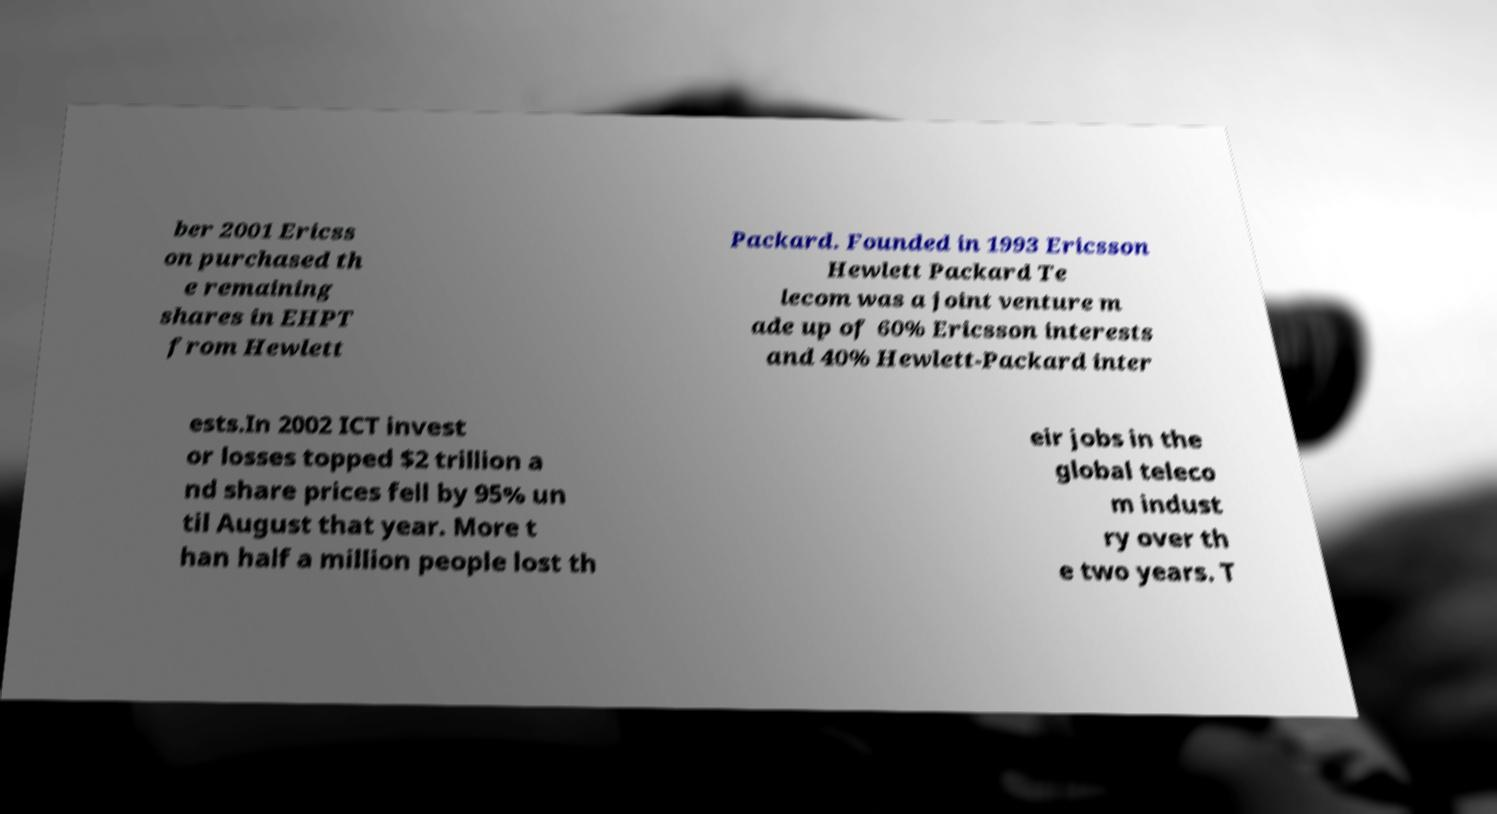Can you read and provide the text displayed in the image?This photo seems to have some interesting text. Can you extract and type it out for me? ber 2001 Ericss on purchased th e remaining shares in EHPT from Hewlett Packard. Founded in 1993 Ericsson Hewlett Packard Te lecom was a joint venture m ade up of 60% Ericsson interests and 40% Hewlett-Packard inter ests.In 2002 ICT invest or losses topped $2 trillion a nd share prices fell by 95% un til August that year. More t han half a million people lost th eir jobs in the global teleco m indust ry over th e two years. T 